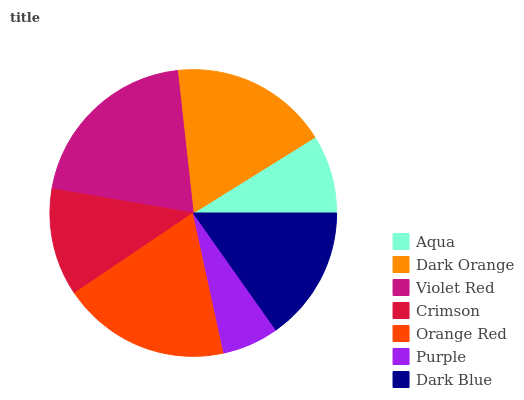Is Purple the minimum?
Answer yes or no. Yes. Is Violet Red the maximum?
Answer yes or no. Yes. Is Dark Orange the minimum?
Answer yes or no. No. Is Dark Orange the maximum?
Answer yes or no. No. Is Dark Orange greater than Aqua?
Answer yes or no. Yes. Is Aqua less than Dark Orange?
Answer yes or no. Yes. Is Aqua greater than Dark Orange?
Answer yes or no. No. Is Dark Orange less than Aqua?
Answer yes or no. No. Is Dark Blue the high median?
Answer yes or no. Yes. Is Dark Blue the low median?
Answer yes or no. Yes. Is Purple the high median?
Answer yes or no. No. Is Violet Red the low median?
Answer yes or no. No. 